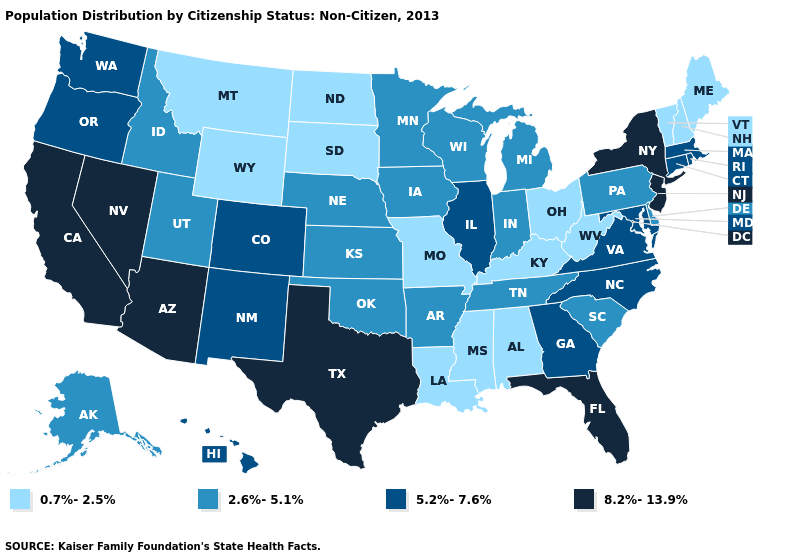Among the states that border Nevada , does Idaho have the lowest value?
Give a very brief answer. Yes. What is the highest value in the USA?
Concise answer only. 8.2%-13.9%. Which states have the lowest value in the USA?
Write a very short answer. Alabama, Kentucky, Louisiana, Maine, Mississippi, Missouri, Montana, New Hampshire, North Dakota, Ohio, South Dakota, Vermont, West Virginia, Wyoming. Which states have the highest value in the USA?
Quick response, please. Arizona, California, Florida, Nevada, New Jersey, New York, Texas. Which states have the lowest value in the USA?
Keep it brief. Alabama, Kentucky, Louisiana, Maine, Mississippi, Missouri, Montana, New Hampshire, North Dakota, Ohio, South Dakota, Vermont, West Virginia, Wyoming. Which states hav the highest value in the Northeast?
Write a very short answer. New Jersey, New York. Which states have the lowest value in the South?
Keep it brief. Alabama, Kentucky, Louisiana, Mississippi, West Virginia. Name the states that have a value in the range 8.2%-13.9%?
Quick response, please. Arizona, California, Florida, Nevada, New Jersey, New York, Texas. Name the states that have a value in the range 8.2%-13.9%?
Short answer required. Arizona, California, Florida, Nevada, New Jersey, New York, Texas. What is the value of Rhode Island?
Be succinct. 5.2%-7.6%. Does Virginia have the lowest value in the South?
Give a very brief answer. No. What is the lowest value in the South?
Short answer required. 0.7%-2.5%. Name the states that have a value in the range 5.2%-7.6%?
Concise answer only. Colorado, Connecticut, Georgia, Hawaii, Illinois, Maryland, Massachusetts, New Mexico, North Carolina, Oregon, Rhode Island, Virginia, Washington. Is the legend a continuous bar?
Short answer required. No. 